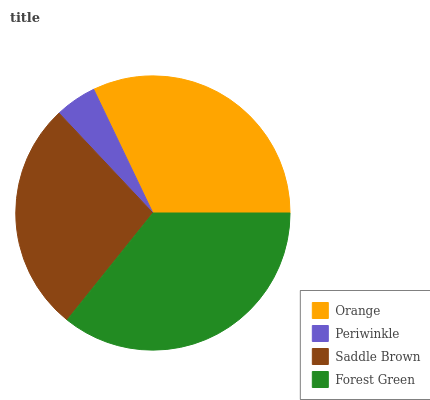Is Periwinkle the minimum?
Answer yes or no. Yes. Is Forest Green the maximum?
Answer yes or no. Yes. Is Saddle Brown the minimum?
Answer yes or no. No. Is Saddle Brown the maximum?
Answer yes or no. No. Is Saddle Brown greater than Periwinkle?
Answer yes or no. Yes. Is Periwinkle less than Saddle Brown?
Answer yes or no. Yes. Is Periwinkle greater than Saddle Brown?
Answer yes or no. No. Is Saddle Brown less than Periwinkle?
Answer yes or no. No. Is Orange the high median?
Answer yes or no. Yes. Is Saddle Brown the low median?
Answer yes or no. Yes. Is Saddle Brown the high median?
Answer yes or no. No. Is Orange the low median?
Answer yes or no. No. 